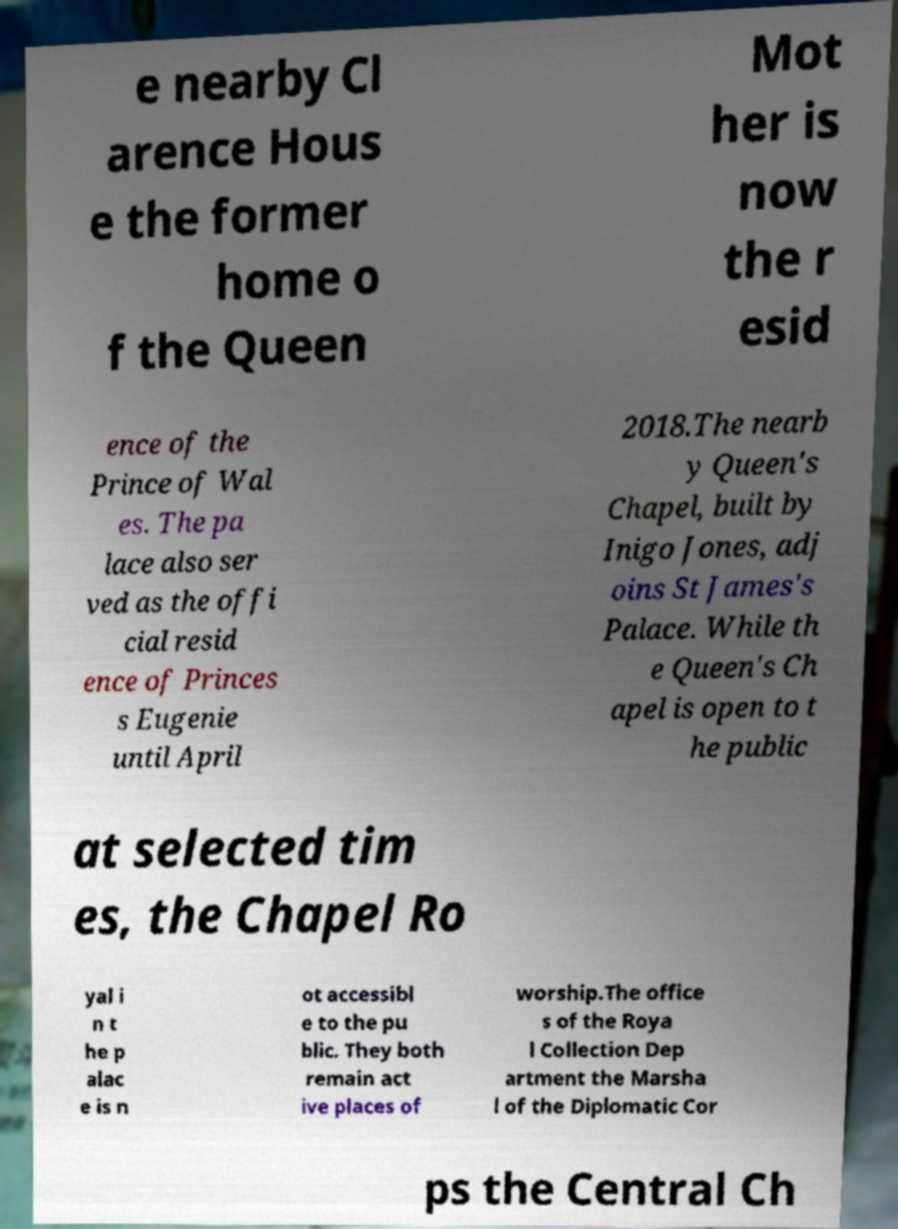Could you extract and type out the text from this image? e nearby Cl arence Hous e the former home o f the Queen Mot her is now the r esid ence of the Prince of Wal es. The pa lace also ser ved as the offi cial resid ence of Princes s Eugenie until April 2018.The nearb y Queen's Chapel, built by Inigo Jones, adj oins St James's Palace. While th e Queen's Ch apel is open to t he public at selected tim es, the Chapel Ro yal i n t he p alac e is n ot accessibl e to the pu blic. They both remain act ive places of worship.The office s of the Roya l Collection Dep artment the Marsha l of the Diplomatic Cor ps the Central Ch 